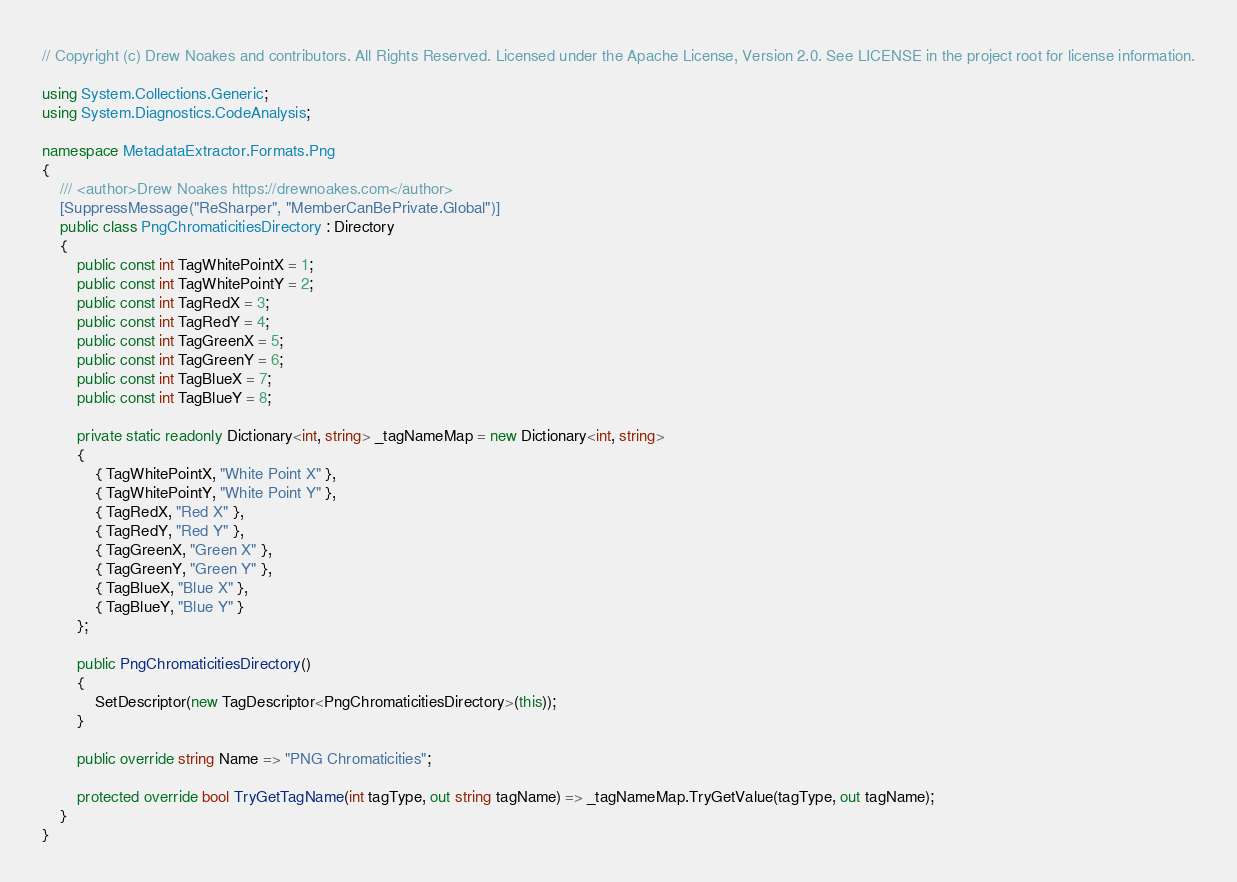<code> <loc_0><loc_0><loc_500><loc_500><_C#_>// Copyright (c) Drew Noakes and contributors. All Rights Reserved. Licensed under the Apache License, Version 2.0. See LICENSE in the project root for license information.

using System.Collections.Generic;
using System.Diagnostics.CodeAnalysis;

namespace MetadataExtractor.Formats.Png
{
    /// <author>Drew Noakes https://drewnoakes.com</author>
    [SuppressMessage("ReSharper", "MemberCanBePrivate.Global")]
    public class PngChromaticitiesDirectory : Directory
    {
        public const int TagWhitePointX = 1;
        public const int TagWhitePointY = 2;
        public const int TagRedX = 3;
        public const int TagRedY = 4;
        public const int TagGreenX = 5;
        public const int TagGreenY = 6;
        public const int TagBlueX = 7;
        public const int TagBlueY = 8;

        private static readonly Dictionary<int, string> _tagNameMap = new Dictionary<int, string>
        {
            { TagWhitePointX, "White Point X" },
            { TagWhitePointY, "White Point Y" },
            { TagRedX, "Red X" },
            { TagRedY, "Red Y" },
            { TagGreenX, "Green X" },
            { TagGreenY, "Green Y" },
            { TagBlueX, "Blue X" },
            { TagBlueY, "Blue Y" }
        };

        public PngChromaticitiesDirectory()
        {
            SetDescriptor(new TagDescriptor<PngChromaticitiesDirectory>(this));
        }

        public override string Name => "PNG Chromaticities";

        protected override bool TryGetTagName(int tagType, out string tagName) => _tagNameMap.TryGetValue(tagType, out tagName);
    }
}
</code> 